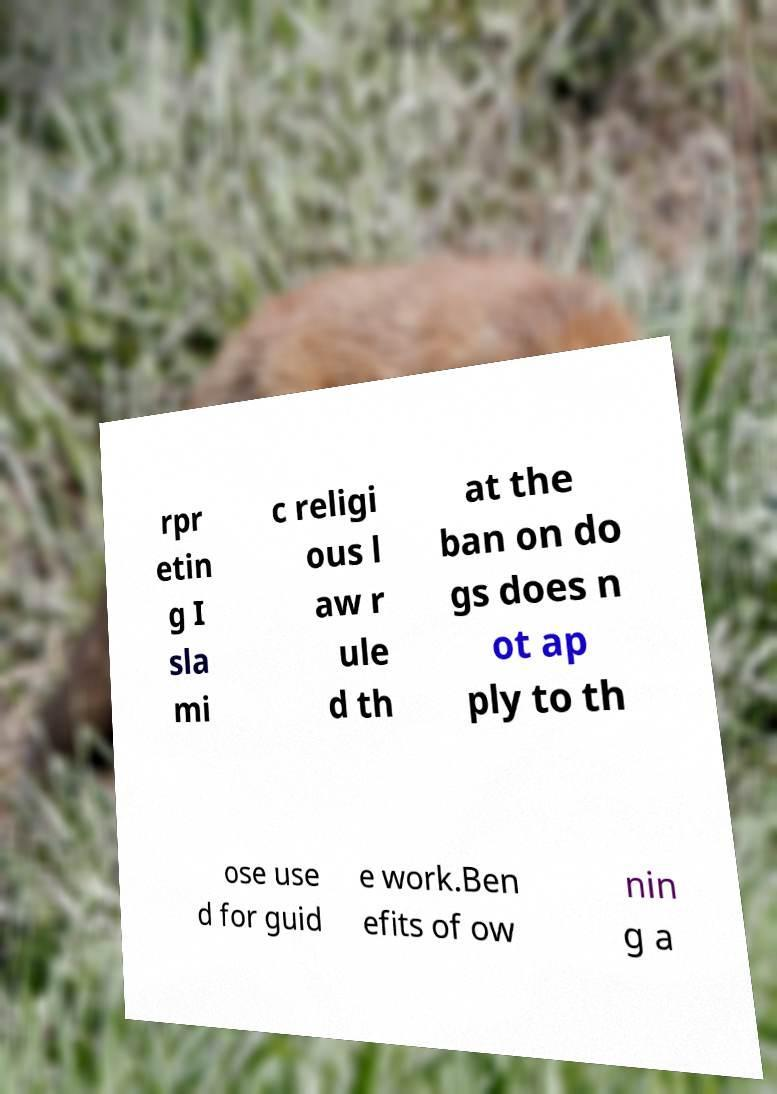Please read and relay the text visible in this image. What does it say? rpr etin g I sla mi c religi ous l aw r ule d th at the ban on do gs does n ot ap ply to th ose use d for guid e work.Ben efits of ow nin g a 